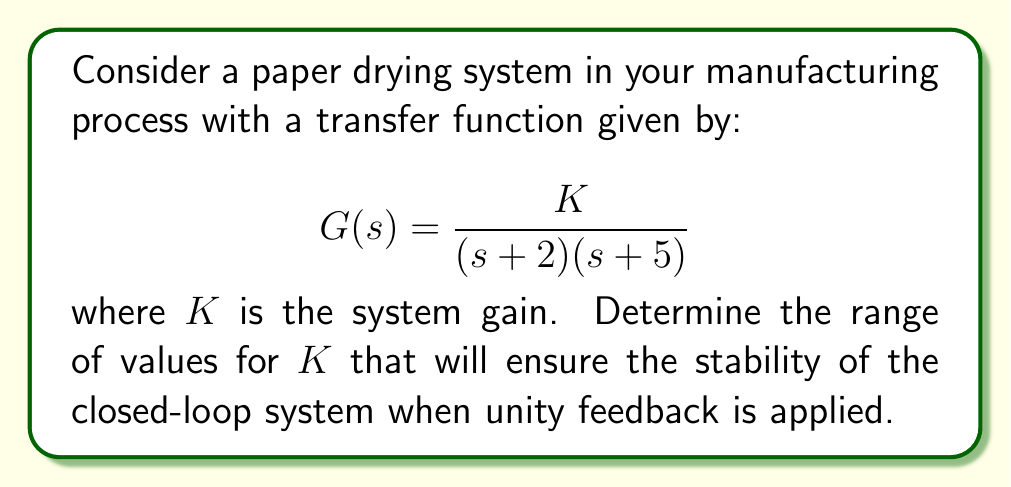Show me your answer to this math problem. To analyze the stability of the closed-loop system, we'll use the Routh-Hurwitz stability criterion. First, let's derive the closed-loop transfer function:

1) The closed-loop transfer function is given by:
   $$T(s) = \frac{G(s)}{1 + G(s)}$$

2) Substituting $G(s)$:
   $$T(s) = \frac{\frac{K}{(s + 2)(s + 5)}}{1 + \frac{K}{(s + 2)(s + 5)}}$$

3) Finding a common denominator:
   $$T(s) = \frac{K}{(s + 2)(s + 5) + K}$$

4) Expanding the denominator:
   $$T(s) = \frac{K}{s^2 + 7s + 10 + K}$$

5) The characteristic equation is:
   $$s^2 + 7s + (10 + K) = 0$$

Now, we'll apply the Routh-Hurwitz criterion:

6) The Routh array is:
   $$\begin{array}{c|cc}
   s^2 & 1 & 10+K \\
   s^1 & 7 & 0 \\
   s^0 & 10+K & 0
   \end{array}$$

7) For stability, all elements in the first column must be positive. We already know that 1 > 0 and 7 > 0, so we need:
   $$10 + K > 0$$

8) Solving this inequality:
   $$K > -10$$

Therefore, the system will be stable for all $K > -10$.
Answer: The paper drying system will be stable for all $K > -10$. 